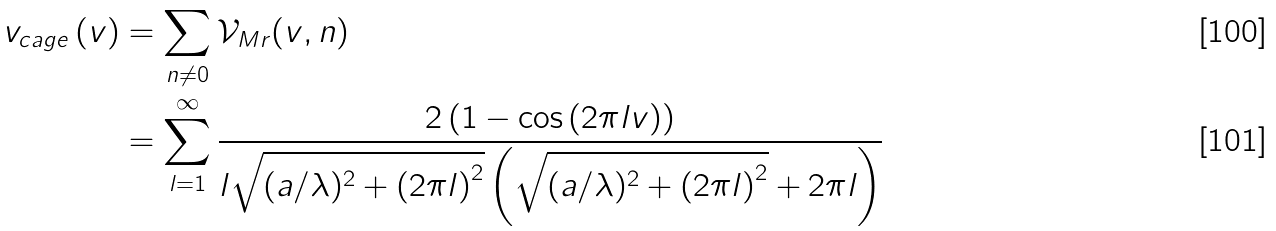<formula> <loc_0><loc_0><loc_500><loc_500>v _ { c a g e } \left ( v \right ) & = \sum _ { n \neq 0 } \mathcal { V } _ { M r } ( v , n ) \\ & = \sum _ { l = 1 } ^ { \infty } \frac { 2 \left ( 1 - \cos \left ( 2 \pi l v \right ) \right ) } { l \sqrt { ( a / \lambda ) ^ { 2 } + \left ( 2 \pi l \right ) ^ { 2 } } \left ( \sqrt { ( a / \lambda ) ^ { 2 } + \left ( 2 \pi l \right ) ^ { 2 } } + 2 \pi l \right ) }</formula> 